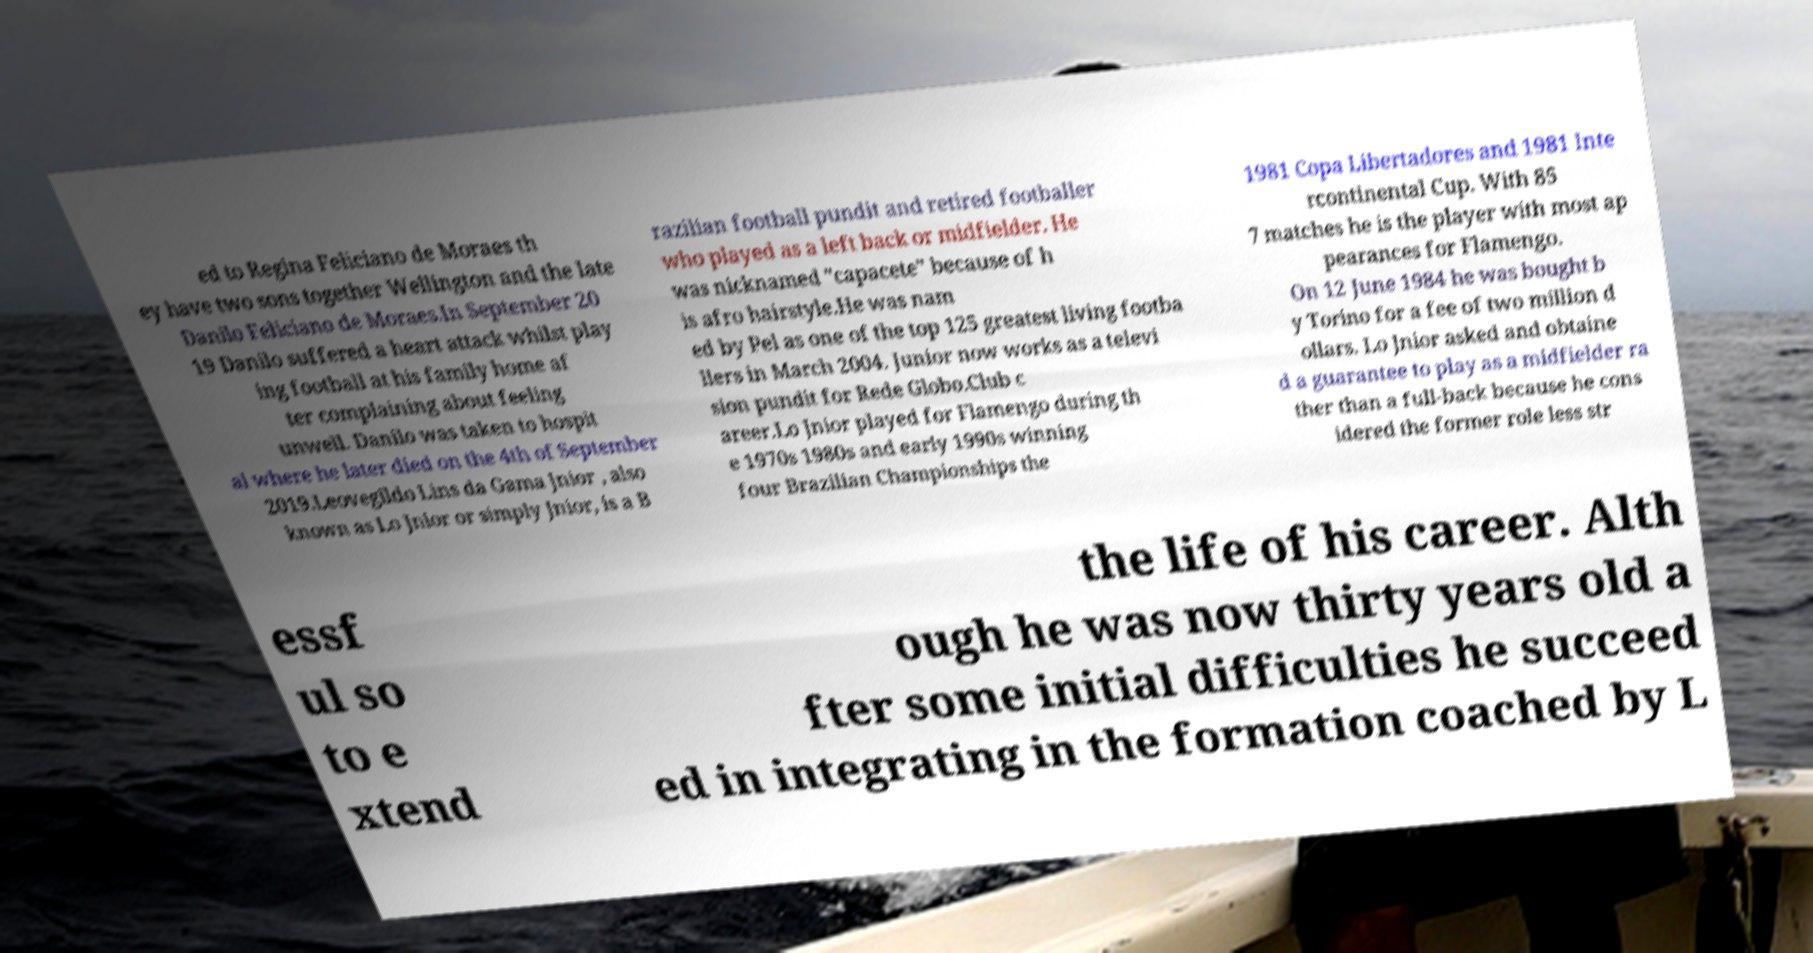Please read and relay the text visible in this image. What does it say? ed to Regina Feliciano de Moraes th ey have two sons together Wellington and the late Danilo Feliciano de Moraes.In September 20 19 Danilo suffered a heart attack whilst play ing football at his family home af ter complaining about feeling unwell. Danilo was taken to hospit al where he later died on the 4th of September 2019.Leovegildo Lins da Gama Jnior , also known as Lo Jnior or simply Jnior, is a B razilian football pundit and retired footballer who played as a left back or midfielder. He was nicknamed "capacete" because of h is afro hairstyle.He was nam ed by Pel as one of the top 125 greatest living footba llers in March 2004. Junior now works as a televi sion pundit for Rede Globo.Club c areer.Lo Jnior played for Flamengo during th e 1970s 1980s and early 1990s winning four Brazilian Championships the 1981 Copa Libertadores and 1981 Inte rcontinental Cup. With 85 7 matches he is the player with most ap pearances for Flamengo. On 12 June 1984 he was bought b y Torino for a fee of two million d ollars. Lo Jnior asked and obtaine d a guarantee to play as a midfielder ra ther than a full-back because he cons idered the former role less str essf ul so to e xtend the life of his career. Alth ough he was now thirty years old a fter some initial difficulties he succeed ed in integrating in the formation coached by L 